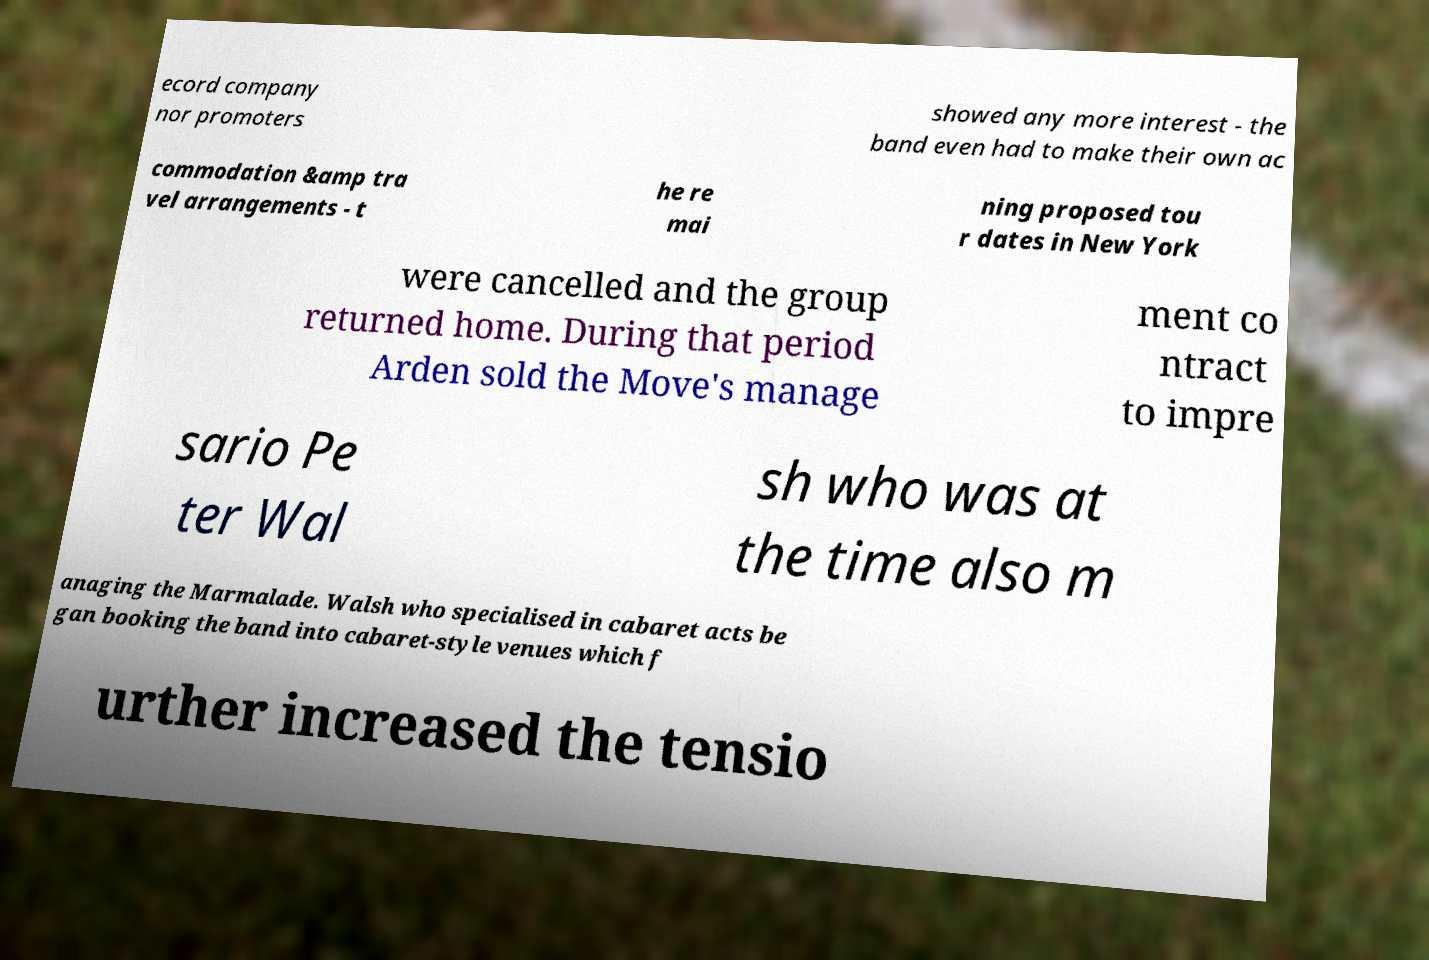Can you accurately transcribe the text from the provided image for me? ecord company nor promoters showed any more interest - the band even had to make their own ac commodation &amp tra vel arrangements - t he re mai ning proposed tou r dates in New York were cancelled and the group returned home. During that period Arden sold the Move's manage ment co ntract to impre sario Pe ter Wal sh who was at the time also m anaging the Marmalade. Walsh who specialised in cabaret acts be gan booking the band into cabaret-style venues which f urther increased the tensio 